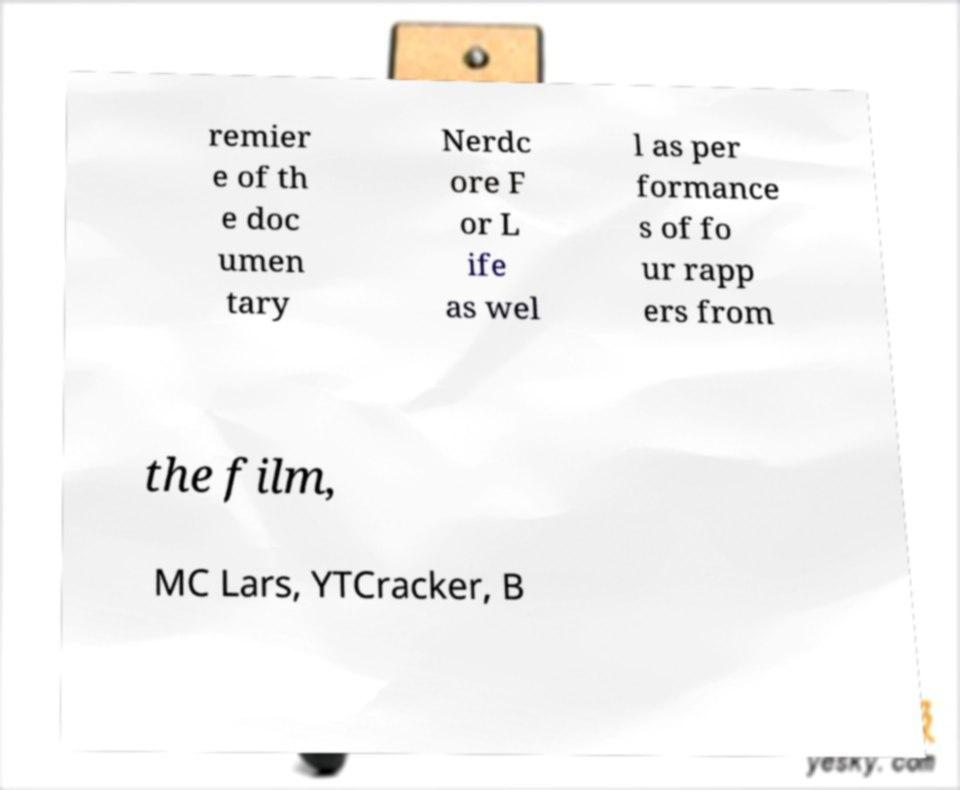Could you assist in decoding the text presented in this image and type it out clearly? remier e of th e doc umen tary Nerdc ore F or L ife as wel l as per formance s of fo ur rapp ers from the film, MC Lars, YTCracker, B 